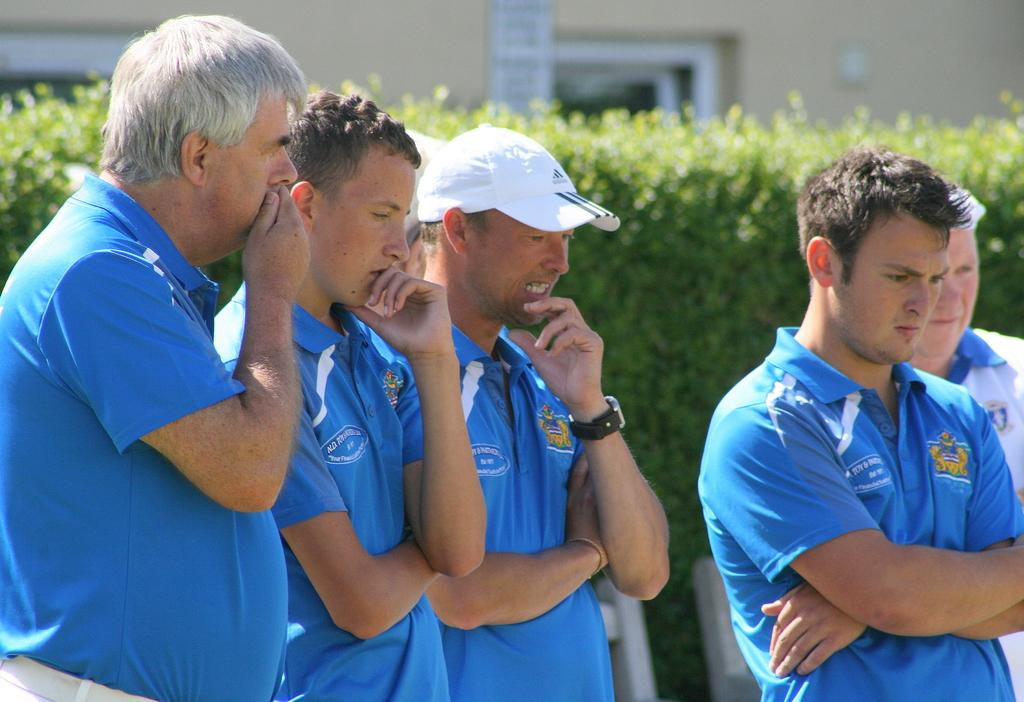How many people are in the image? There is a group of people standing in the image, but the exact number cannot be determined from the provided facts. What can be seen in the background of the image? There is a building in the background of the image. What type of vegetation is present in the image? There are plants in the image. What type of furniture is visible in the image? There are chairs in the image. Can you see a receipt on the ground in the image? There is no mention of a receipt in the provided facts, so it cannot be determined if one is present in the image. Is there a pet visible in the image? There is no mention of a pet in the provided facts, so it cannot be determined if one is present in the image. 